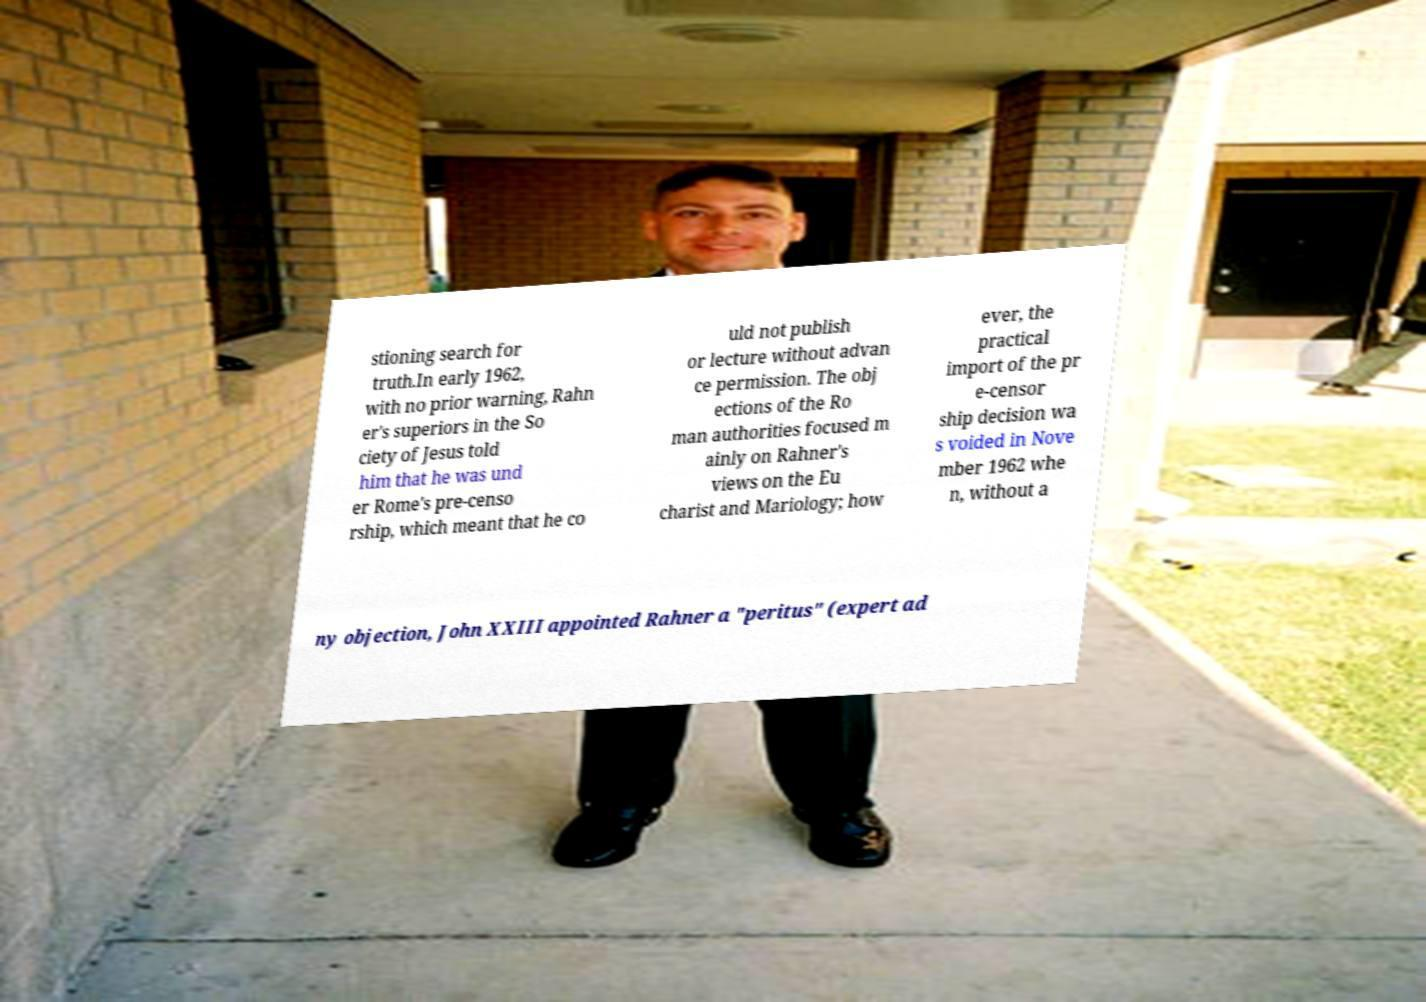Please identify and transcribe the text found in this image. stioning search for truth.In early 1962, with no prior warning, Rahn er's superiors in the So ciety of Jesus told him that he was und er Rome's pre-censo rship, which meant that he co uld not publish or lecture without advan ce permission. The obj ections of the Ro man authorities focused m ainly on Rahner's views on the Eu charist and Mariology; how ever, the practical import of the pr e-censor ship decision wa s voided in Nove mber 1962 whe n, without a ny objection, John XXIII appointed Rahner a "peritus" (expert ad 